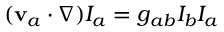Convert formula to latex. <formula><loc_0><loc_0><loc_500><loc_500>\begin{array} { r } { ( v _ { a } \cdot \nabla ) I _ { a } = g _ { a b } I _ { b } I _ { a } } \end{array}</formula> 